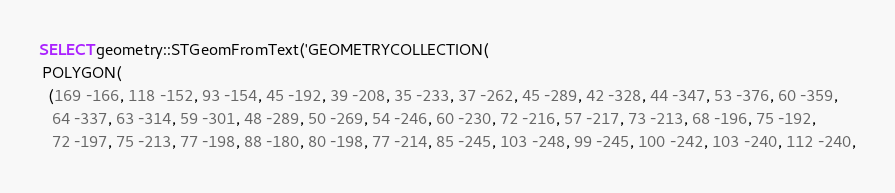<code> <loc_0><loc_0><loc_500><loc_500><_SQL_>SELECT geometry::STGeomFromText('GEOMETRYCOLLECTION(
 POLYGON(
  (169 -166, 118 -152, 93 -154, 45 -192, 39 -208, 35 -233, 37 -262, 45 -289, 42 -328, 44 -347, 53 -376, 60 -359, 
   64 -337, 63 -314, 59 -301, 48 -289, 50 -269, 54 -246, 60 -230, 72 -216, 57 -217, 73 -213, 68 -196, 75 -192, 
   72 -197, 75 -213, 77 -198, 88 -180, 80 -198, 77 -214, 85 -245, 103 -248, 99 -245, 100 -242, 103 -240, 112 -240,</code> 